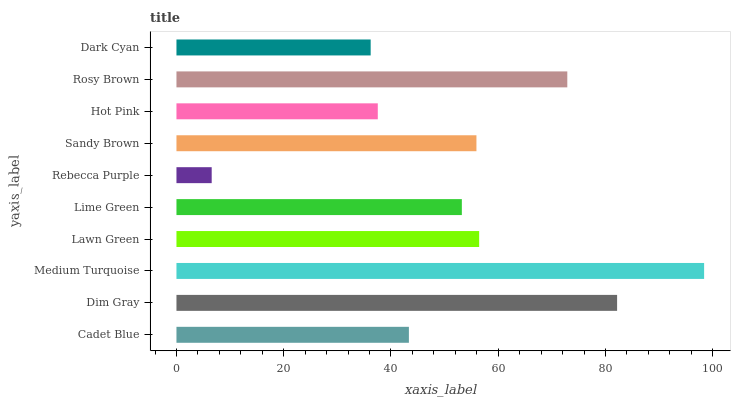Is Rebecca Purple the minimum?
Answer yes or no. Yes. Is Medium Turquoise the maximum?
Answer yes or no. Yes. Is Dim Gray the minimum?
Answer yes or no. No. Is Dim Gray the maximum?
Answer yes or no. No. Is Dim Gray greater than Cadet Blue?
Answer yes or no. Yes. Is Cadet Blue less than Dim Gray?
Answer yes or no. Yes. Is Cadet Blue greater than Dim Gray?
Answer yes or no. No. Is Dim Gray less than Cadet Blue?
Answer yes or no. No. Is Sandy Brown the high median?
Answer yes or no. Yes. Is Lime Green the low median?
Answer yes or no. Yes. Is Hot Pink the high median?
Answer yes or no. No. Is Rebecca Purple the low median?
Answer yes or no. No. 